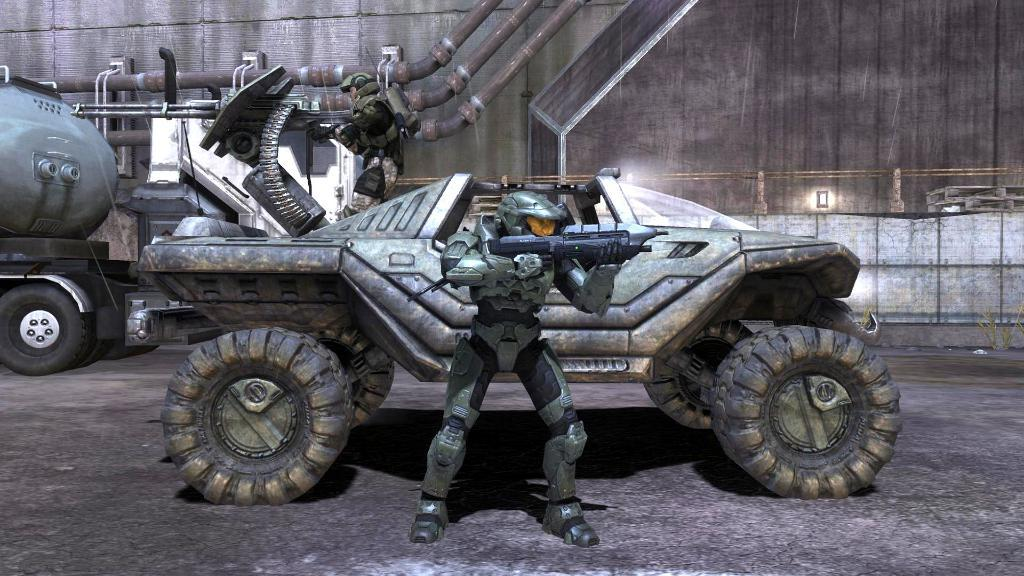What type of image is being described? The image is an animated image. What can be seen moving in the image? There are vehicles present in the image. What is the person in the image wearing? The person in the image is wearing armor and holding a gun. How many girls are present in the image? There is no mention of girls in the provided facts, so we cannot determine their presence in the image. --- Facts: 1. There is a person sitting on a chair in the image. 2. The person is holding a book. 3. The book has a blue cover. 4. There is a table next to the chair. 5. The table has a lamp on it. Absurd Topics: ocean, parrot, bicycle Conversation: What is the person in the image doing? The person in the image is sitting on a chair. What is the person holding in the image? The person is holding a book. What color is the book's cover? The book has a blue cover. What is on the table next to the chair? There is a lamp on the table. Reasoning: Let's think step by step in order to produce the conversation. We start by identifying the conversation by describing the main subject in the image, which is the person sitting on a chair. Then, we expand the conversation to include the book the person is holding, noting its color. Finally, we describe the table and the lamp on it. Absurd Question/Answer: Can you see the ocean in the image? There is no mention of an ocean in the provided facts, so we cannot determine its presence in the image. 